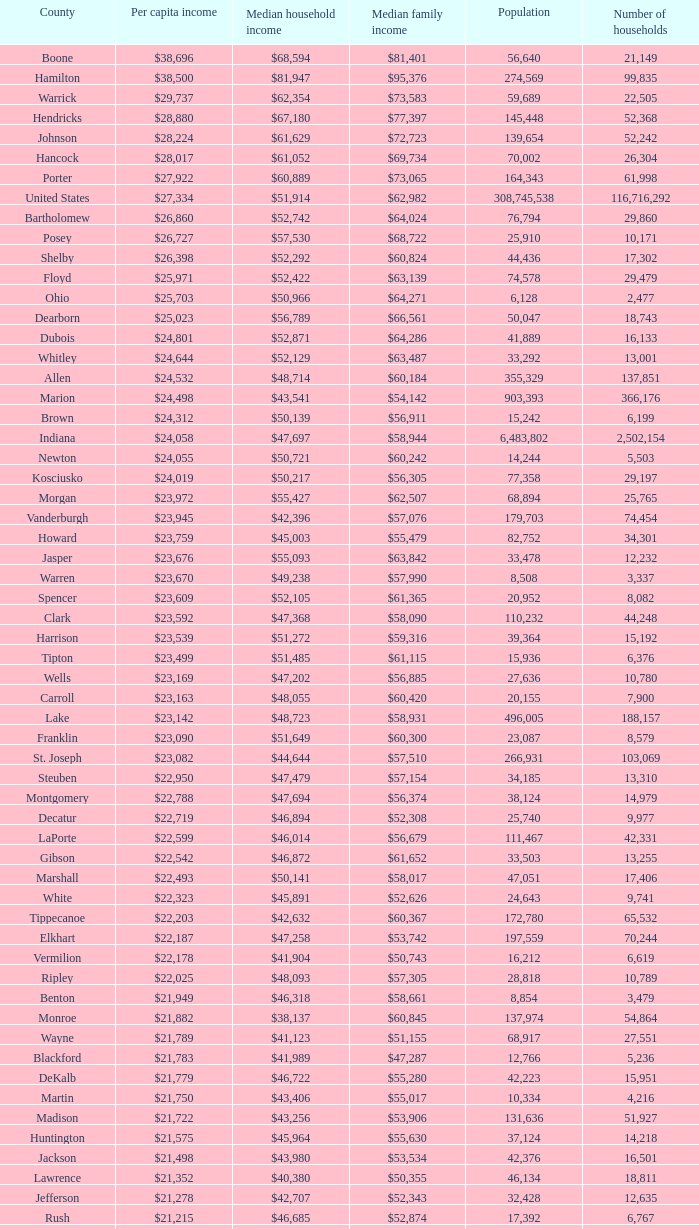Identify the county with a median household income of $46,872. Gibson. 